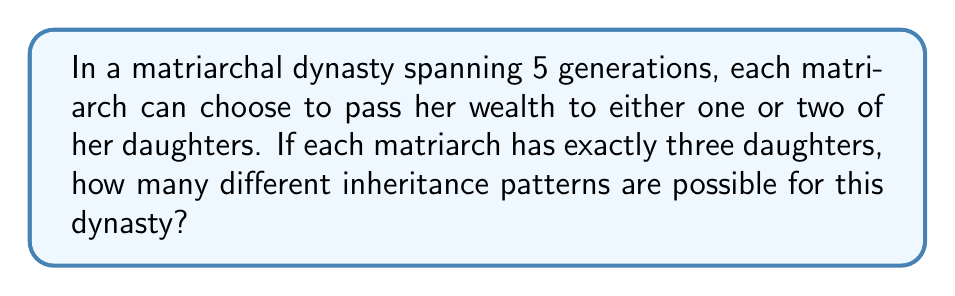Give your solution to this math problem. Let's approach this step-by-step:

1) First, we need to understand what our choices are at each generation:
   - Each matriarch can choose to pass wealth to either 1 or 2 daughters out of 3.

2) Let's calculate the number of choices at each generation:
   - Choosing 1 out of 3: $\binom{3}{1} = 3$
   - Choosing 2 out of 3: $\binom{3}{2} = 3$
   - Total choices per generation: $3 + 3 = 6$

3) Now, we need to consider that this pattern continues for 5 generations.

4) In each generation, we have 6 choices, and these choices are independent of the choices in other generations.

5) When we have a series of independent choices, we multiply the number of possibilities for each choice.

6) Therefore, the total number of possible inheritance patterns is:

   $$ 6 \times 6 \times 6 \times 6 \times 6 = 6^5 $$

7) Calculating this:
   $$ 6^5 = 7,776 $$

Thus, there are 7,776 different possible inheritance patterns for this matriarchal dynasty over 5 generations.
Answer: 7,776 